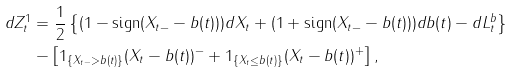Convert formula to latex. <formula><loc_0><loc_0><loc_500><loc_500>d Z _ { t } ^ { 1 } & = \frac { 1 } { 2 } \left \{ ( 1 - \text {sign} ( X _ { t - } - b ( t ) ) ) d X _ { t } + ( 1 + \text {sign} ( X _ { t - } - b ( t ) ) ) d b ( t ) - d L _ { t } ^ { b } \right \} \\ & - \left [ 1 _ { \{ X _ { t - } > b ( t ) \} } ( X _ { t } - b ( t ) ) ^ { - } + 1 _ { \{ X _ { t } \leq b ( t ) \} } ( X _ { t } - b ( t ) ) ^ { + } \right ] ,</formula> 